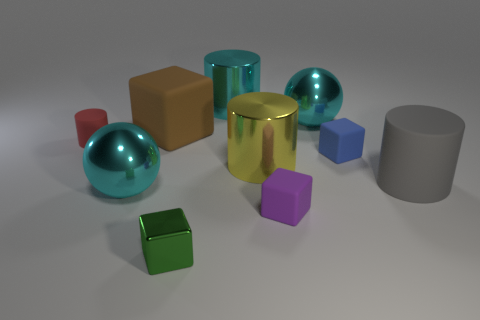There is a matte object that is in front of the gray rubber thing; what is its shape?
Provide a short and direct response. Cube. Does the red thing have the same shape as the gray object?
Give a very brief answer. Yes. Are there the same number of purple rubber blocks left of the red rubber object and small brown shiny cylinders?
Give a very brief answer. Yes. The tiny blue matte thing is what shape?
Your answer should be very brief. Cube. Is there any other thing that is the same color as the large matte cylinder?
Your answer should be compact. No. There is a cyan metallic object in front of the red rubber cylinder; does it have the same size as the rubber cylinder left of the large cyan metal cylinder?
Give a very brief answer. No. The shiny thing in front of the big sphere in front of the large gray matte thing is what shape?
Your answer should be compact. Cube. There is a purple object; is its size the same as the matte object right of the blue object?
Offer a terse response. No. How big is the brown rubber thing that is behind the rubber cylinder on the right side of the rubber thing that is behind the small red cylinder?
Your answer should be compact. Large. How many objects are cyan metallic things right of the tiny purple cube or red things?
Keep it short and to the point. 2. 